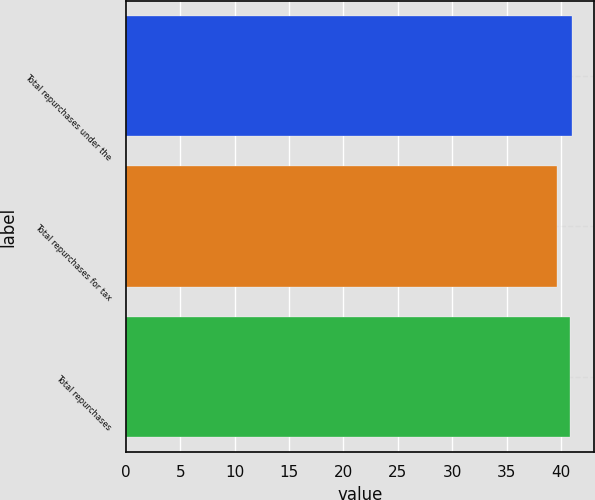Convert chart. <chart><loc_0><loc_0><loc_500><loc_500><bar_chart><fcel>Total repurchases under the<fcel>Total repurchases for tax<fcel>Total repurchases<nl><fcel>40.99<fcel>39.63<fcel>40.86<nl></chart> 